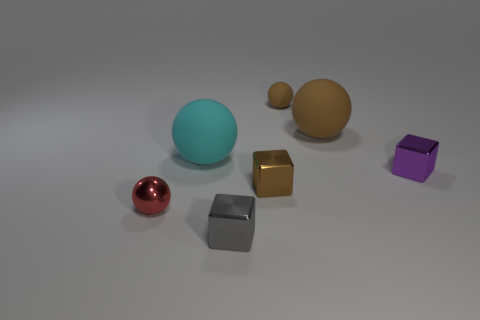What number of other things are there of the same size as the purple object?
Your response must be concise. 4. Do the brown metal thing that is on the left side of the tiny matte ball and the cyan object on the right side of the red sphere have the same size?
Your answer should be very brief. No. How many things are either large brown matte things or tiny brown things that are behind the purple shiny object?
Your response must be concise. 2. How big is the rubber ball that is on the left side of the gray thing?
Offer a very short reply. Large. Are there fewer objects that are to the right of the tiny brown matte object than cyan balls on the left side of the cyan matte sphere?
Your response must be concise. No. What material is the object that is both in front of the cyan ball and to the left of the gray thing?
Give a very brief answer. Metal. The shiny thing that is to the right of the brown thing in front of the purple thing is what shape?
Offer a terse response. Cube. How many cyan things are matte balls or large rubber objects?
Make the answer very short. 1. There is a gray metal thing; are there any tiny metallic cubes left of it?
Your answer should be compact. No. How big is the cyan ball?
Offer a very short reply. Large. 